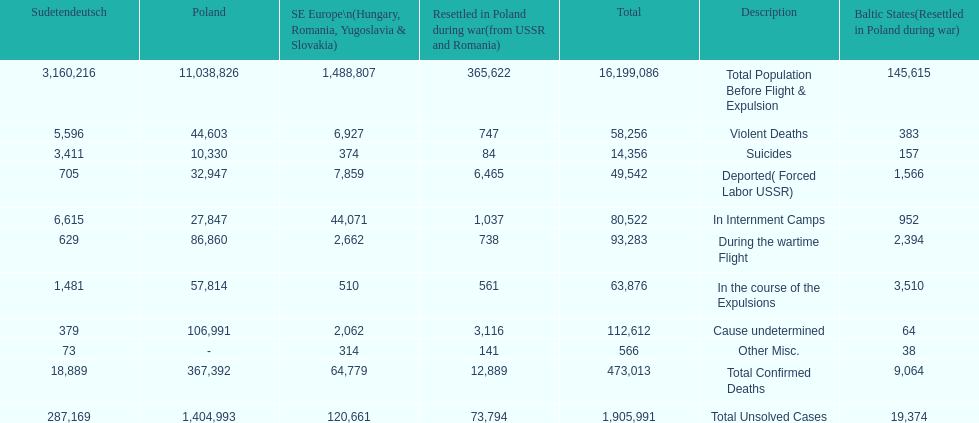What is the difference between suicides in poland and sudetendeutsch? 6919. 